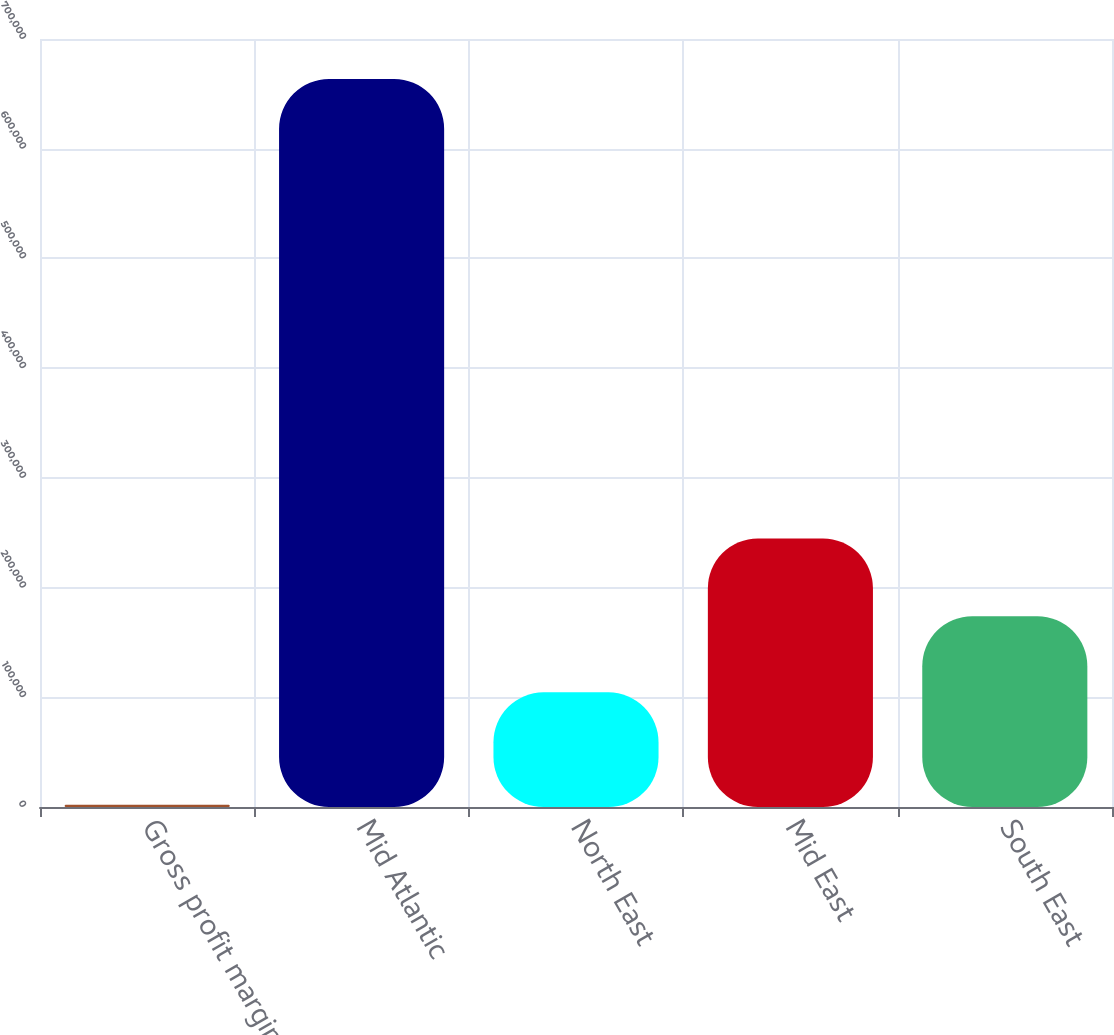Convert chart to OTSL. <chart><loc_0><loc_0><loc_500><loc_500><bar_chart><fcel>Gross profit margin<fcel>Mid Atlantic<fcel>North East<fcel>Mid East<fcel>South East<nl><fcel>2017<fcel>663650<fcel>104501<fcel>244832<fcel>173961<nl></chart> 